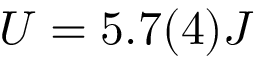Convert formula to latex. <formula><loc_0><loc_0><loc_500><loc_500>U = 5 . 7 ( 4 ) J</formula> 